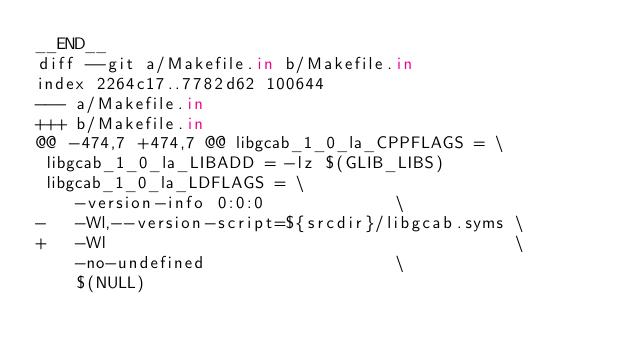<code> <loc_0><loc_0><loc_500><loc_500><_Ruby_>__END__
diff --git a/Makefile.in b/Makefile.in
index 2264c17..7782d62 100644
--- a/Makefile.in
+++ b/Makefile.in
@@ -474,7 +474,7 @@ libgcab_1_0_la_CPPFLAGS = \
 libgcab_1_0_la_LIBADD = -lz $(GLIB_LIBS)
 libgcab_1_0_la_LDFLAGS = \
 	-version-info 0:0:0				\
-	-Wl,--version-script=${srcdir}/libgcab.syms	\
+	-Wl                                     	\
 	-no-undefined					\
 	$(NULL)

</code> 